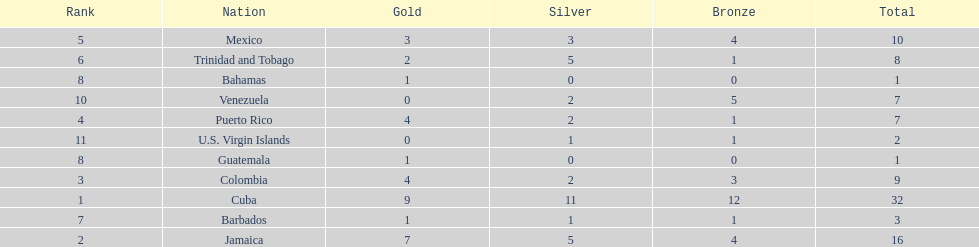What is the total number of gold medals awarded between these 11 countries? 32. 